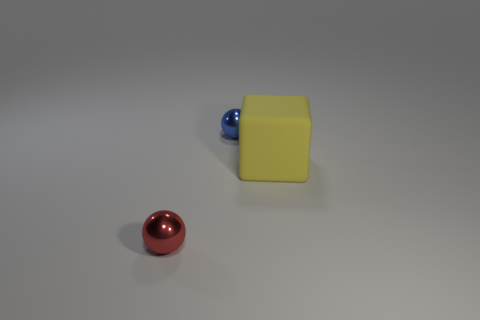Are there any other things that are made of the same material as the large yellow cube?
Offer a very short reply. No. What shape is the metal object that is in front of the large matte object?
Offer a terse response. Sphere. How many other red balls have the same size as the red sphere?
Your answer should be compact. 0. What number of things are either balls that are behind the red sphere or small cyan spheres?
Ensure brevity in your answer.  1. Does the tiny blue sphere have the same material as the small object in front of the rubber cube?
Ensure brevity in your answer.  Yes. Are there any red spheres that have the same material as the blue ball?
Provide a succinct answer. Yes. How many things are small metallic objects in front of the blue object or small metallic balls that are to the right of the red thing?
Provide a succinct answer. 2. There is a small blue thing; is its shape the same as the metallic thing that is in front of the yellow matte thing?
Your response must be concise. Yes. How many other objects are the same shape as the big thing?
Provide a succinct answer. 0. How many objects are red balls or yellow rubber things?
Offer a terse response. 2. 